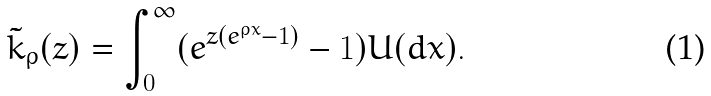Convert formula to latex. <formula><loc_0><loc_0><loc_500><loc_500>\tilde { k } _ { \rho } ( z ) = \int _ { 0 } ^ { \infty } ( e ^ { z ( e ^ { \rho x } - 1 ) } - 1 ) U ( d x ) .</formula> 